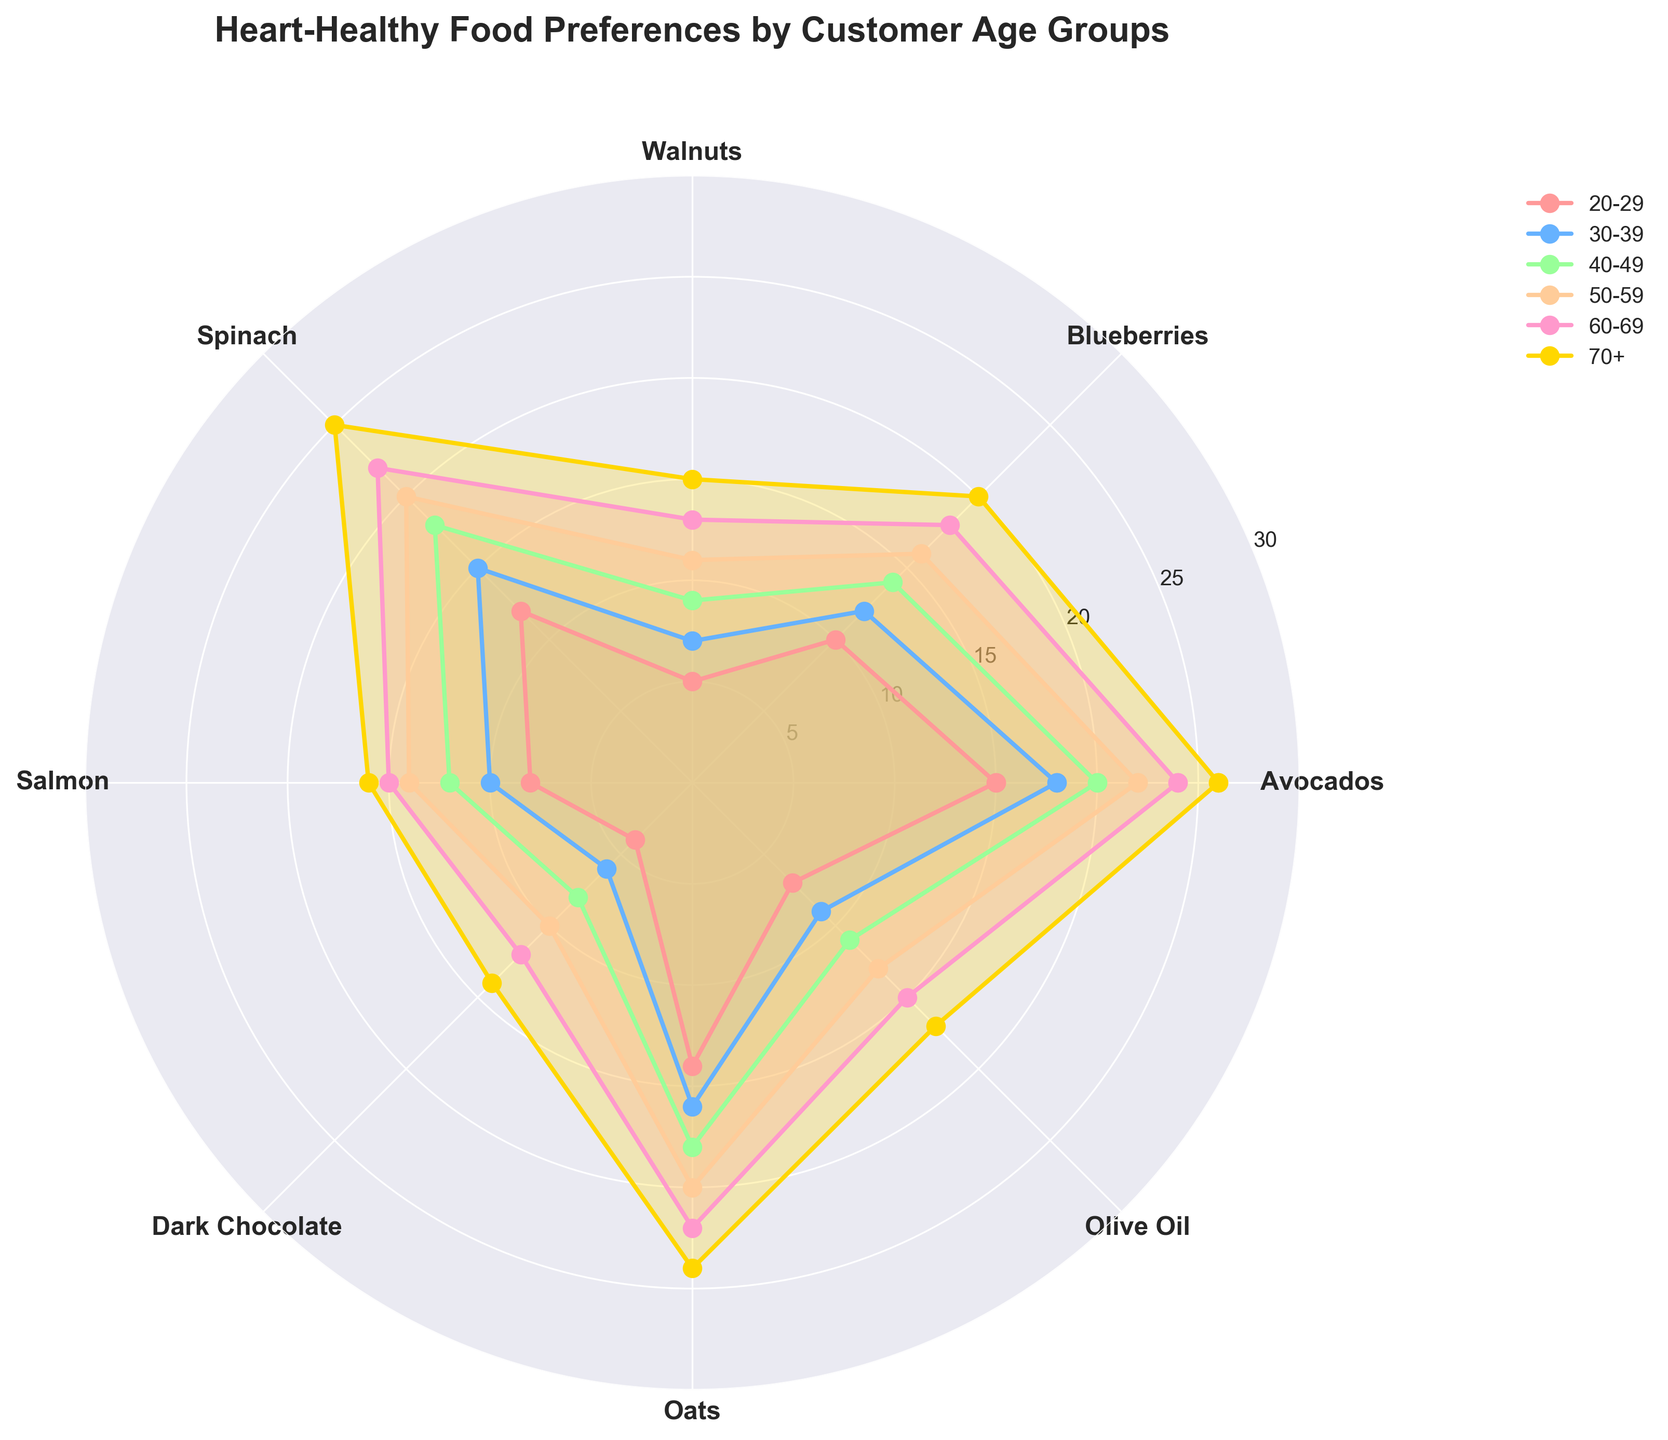What is the title of the figure? The title of the figure is located at the top and is displayed prominently. The title reads, "Heart-Healthy Food Preferences by Customer Age Groups."
Answer: Heart-Healthy Food Preferences by Customer Age Groups What are the categories of heart-healthy foods shown in the chart? The categories of heart-healthy foods are displayed as labels around the edge of the polar plot, representing different segments. The labels read: "Avocados, Blueberries, Walnuts, Spinach, Salmon, Dark Chocolate, Oats, Olive Oil."
Answer: Avocados, Blueberries, Walnuts, Spinach, Salmon, Dark Chocolate, Oats, Olive Oil Which age group shows the highest preference for avocados? To find the age group with the highest preference for avocados, look at the points corresponding to avocados (the first category) and compare the values. The largest value in the avocados segment corresponds to the age group 70+.
Answer: 70+ What are the preferences for salmon in the 50-59 and 60-69 age groups, and what is their difference? To determine preferences, look at the points on the plot for salmon (the fifth category) for the 50-59 and 60-69 age groups. The 50-59 age group has a preference value of 14, while the 60-69 age group has a preference value of 15. The difference is 15 - 14.
Answer: 1 How does the preference of oats change as age increases from 20-29 to 70+? To analyze the change, follow the values corresponding to oats (the seventh category) across all age groups. The values are 14, 16, 18, 20, 22, and 24, showing a steady increase.
Answer: Increases steadily What category shows the most equal preference across all age groups? Look for the food category where the plot lines and filled areas are the most similar in length and shape for all age groups. "Salmon" displays relatively equal preferences compared to others.
Answer: Salmon For which age group is the preference for dark chocolate the lowest? Identify the points on the plot corresponding to dark chocolate (the sixth category) and find the age group with the smallest value. The 20-29 age group has the lowest preference for dark chocolate, with a value of 4.
Answer: 20-29 Which age group prefers olive oil more: 30-39 or 40-49? Compare the points and filled areas for olive oil (the eighth category) for the age groups 30-39 and 40-49. The 40-49 age group has a larger value (11) compared to the 30-39 age group (9).
Answer: 40-49 What's the overall trend in the preference for spinach across increasing age groups? Examine the values for spinach (the fourth category) for all age groups, observing how they change. The values are 12, 15, 18, 20, 22, and 25, indicating an increasing trend.
Answer: Increasing trend Which two age groups have the smallest difference in their preference for blueberries? Compare the preferences for blueberries (the second category) across all age groups to find the smallest difference. The 60-69 and 70+ age groups have the smallest difference, with values of 18 and 20, respectively. The difference is 2.
Answer: 60-69 and 70+ 